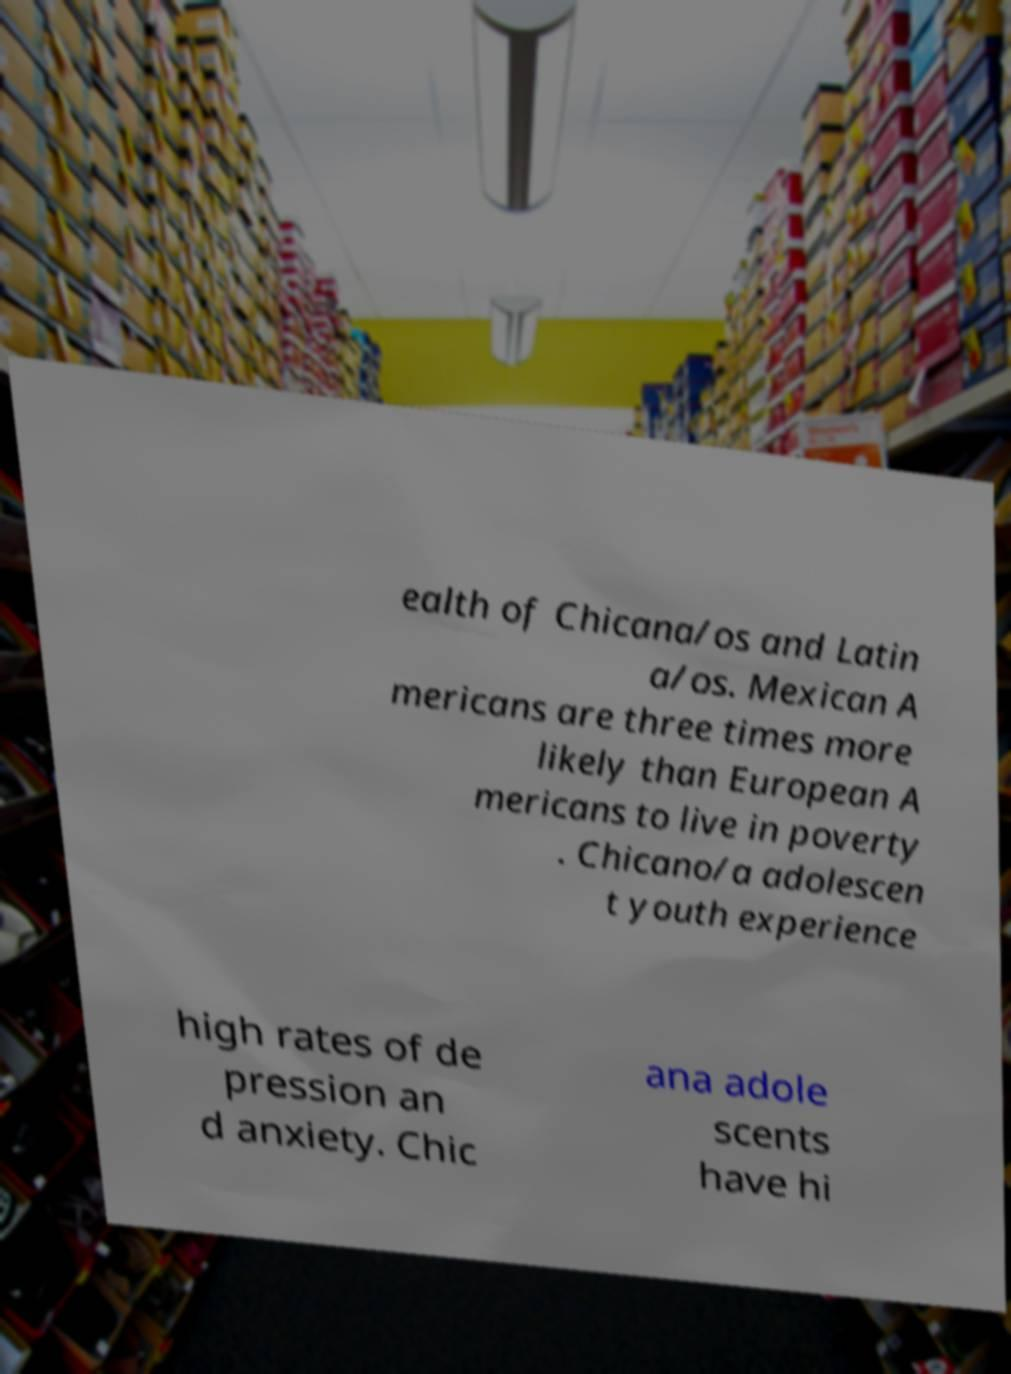There's text embedded in this image that I need extracted. Can you transcribe it verbatim? ealth of Chicana/os and Latin a/os. Mexican A mericans are three times more likely than European A mericans to live in poverty . Chicano/a adolescen t youth experience high rates of de pression an d anxiety. Chic ana adole scents have hi 